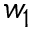<formula> <loc_0><loc_0><loc_500><loc_500>w _ { 1 }</formula> 